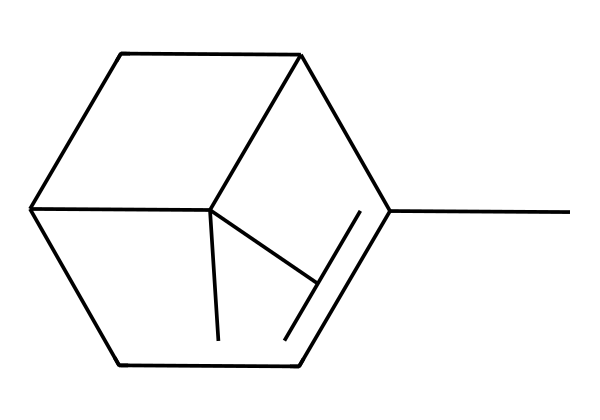How many carbon atoms are in the structure? The SMILES representation includes several 'C' letters, which represent carbon atoms. Counting these in the given SMILES shows there are 10 carbon atoms.
Answer: ten What is the main functional group present in pinene? The SMILES represents a cyclic structure with double bonds, which indicates the presence of alkene functional groups (C=C). Thus, the main functional group is alkene.
Answer: alkene Is pinene a saturated or unsaturated compound? By identifying the double bonds in the structure, we can see that the presence of these double bonds means the compound is not fully saturated with hydrogen atoms, indicating that it is unsaturated.
Answer: unsaturated What type of molecule is pinene classified as? Pinene has a structural motif that falls under terpenes due to its isoprene units and its presence in essential oils found in various plants.
Answer: terpene How many rings are present in the structure? Examining the structure as described by the SMILES notation shows the arrangement of carbons forms two connected ring structures (indicated by the 'C1' and 'C2' notation). This indicates that pinene contains two rings.
Answer: two What kind of isomerism is present in pinene? The structure can have variations in the arrangement of atoms or orientations of bonds, which indicates that pinene exhibits stereoisomerism. This occurs due to double bonds and ring structures that allow for different spatial arrangements.
Answer: stereoisomerism 